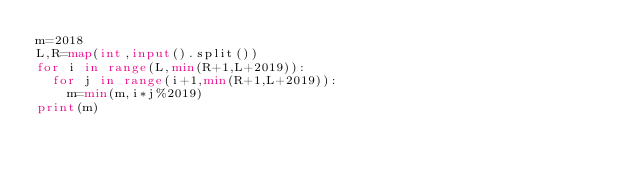<code> <loc_0><loc_0><loc_500><loc_500><_Python_>m=2018
L,R=map(int,input().split())
for i in range(L,min(R+1,L+2019)):
  for j in range(i+1,min(R+1,L+2019)):
    m=min(m,i*j%2019)
print(m)</code> 